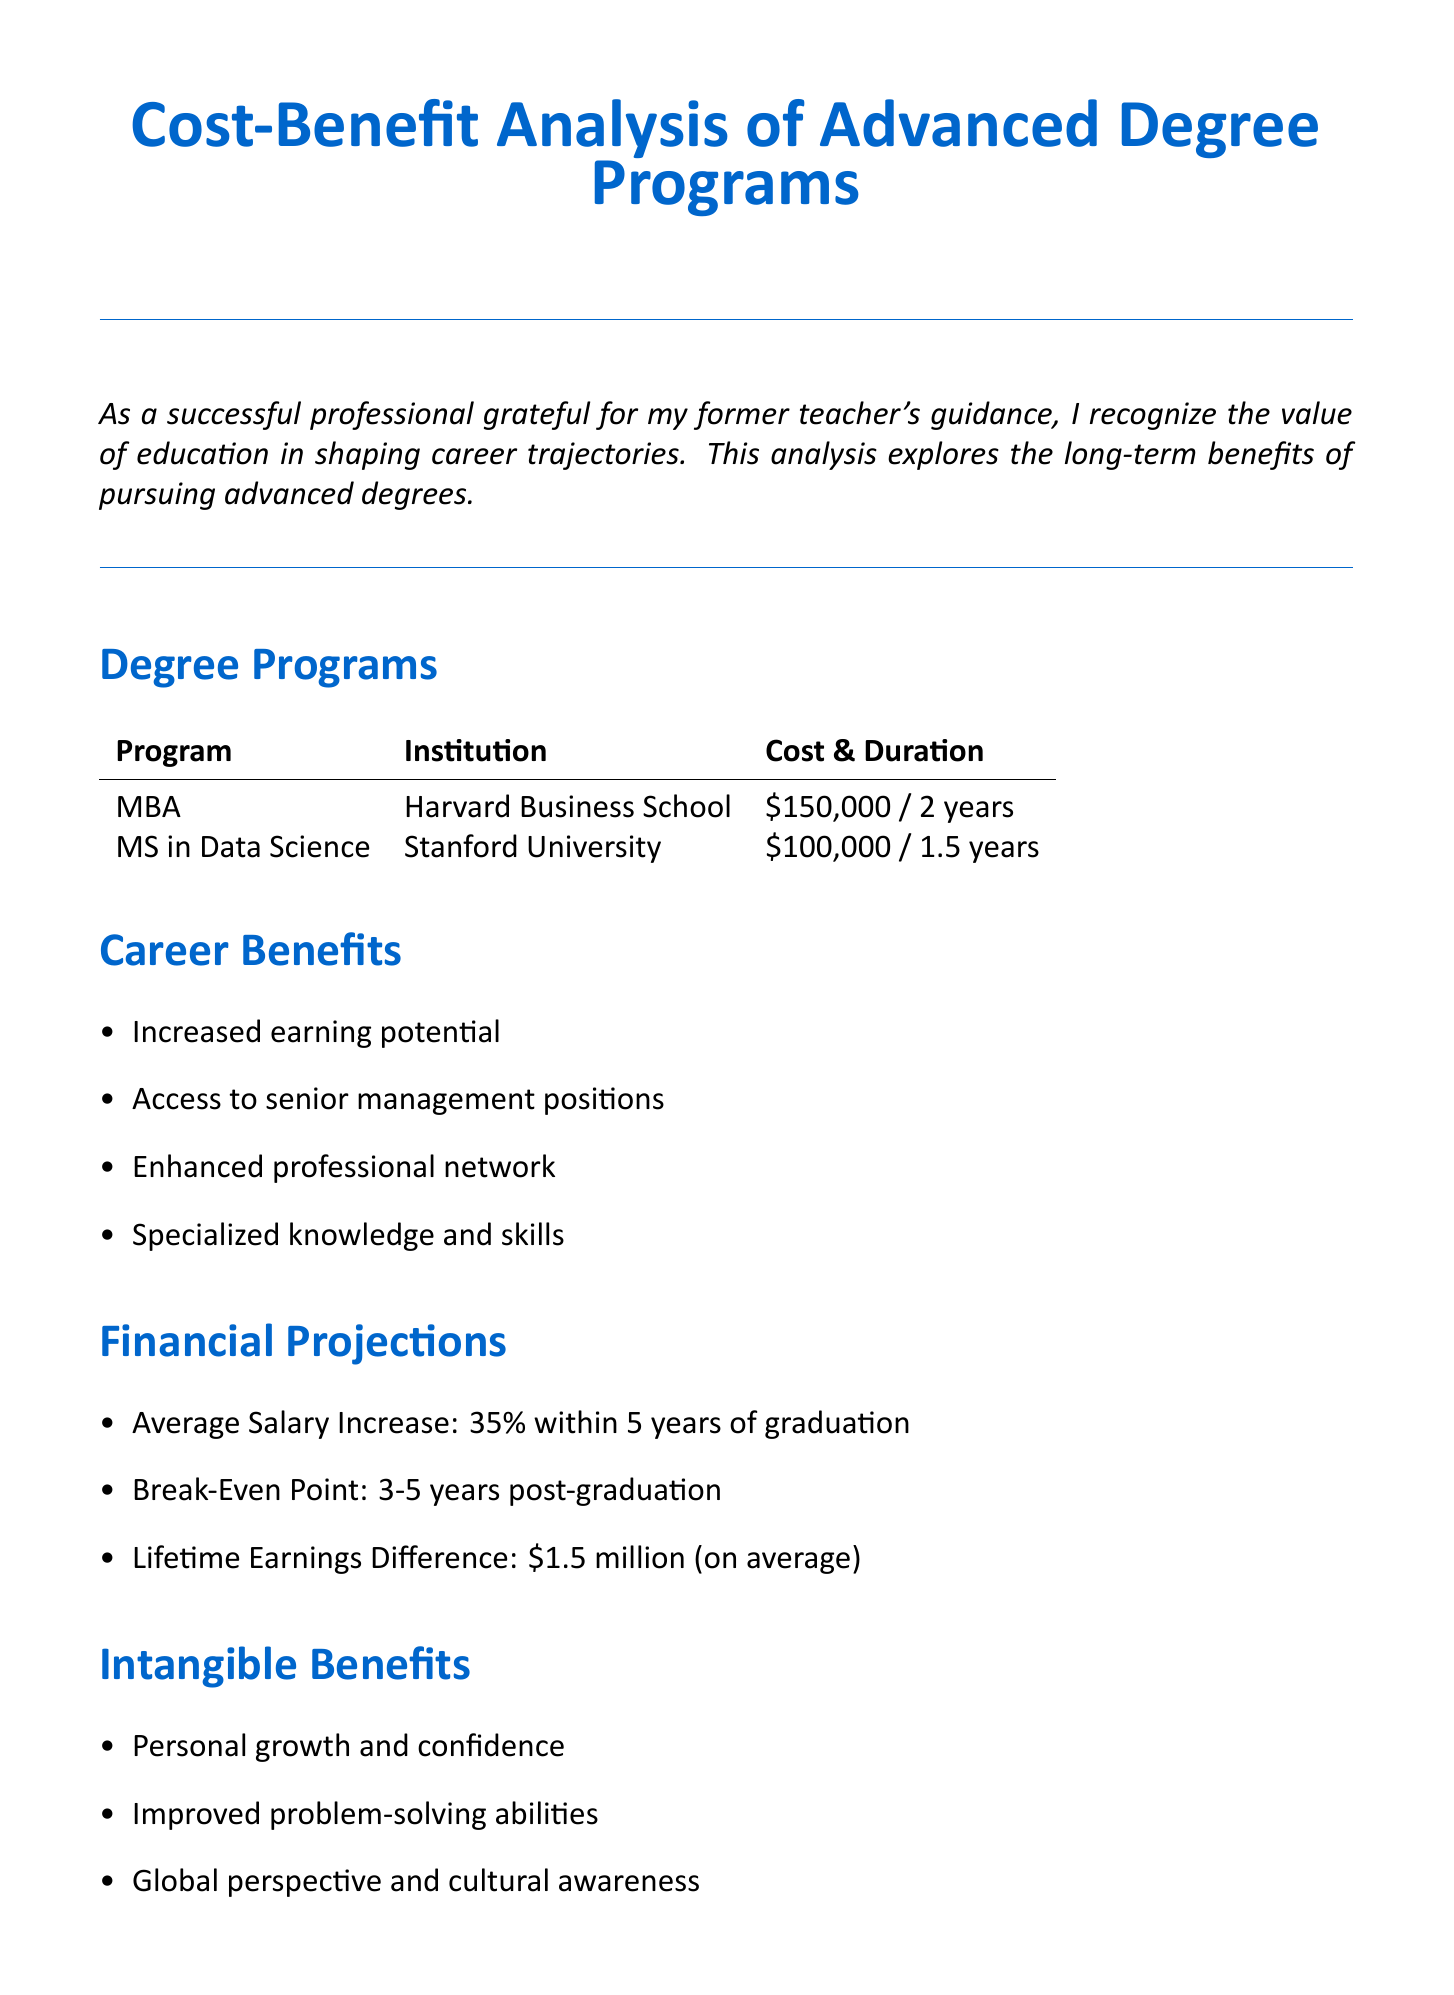What is the title of the document? The title of the document is specified at the beginning, summarizing the content focus.
Answer: Cost-Benefit Analysis of Advanced Degree Programs: Long-Term Career Benefits What are the two degree programs listed? The document provides two specific advanced degree programs as examples.
Answer: MBA, MS in Data Science What is the cost of the Master of Business Administration? The cost of the MBA program is stated in the degree programs section.
Answer: $150,000 What is the average salary increase mentioned? The average salary increase is an important financial projection highlighted in the analysis.
Answer: 35% within 5 years of graduation What is the lifetime earnings difference for graduates? The document summarizes the financial benefit in terms of lifetime earnings difference.
Answer: $1.5 million (on average) What are two intangible benefits mentioned? The intangible benefits section lists important personal growth aspects related to advanced degrees.
Answer: Personal growth and confidence; Improved problem-solving abilities How long does it take to break even after graduation? The break-even point is specified in the financial projections and indicates payback time.
Answer: 3-5 years post-graduation What institution offers the Master of Science in Data Science? The institution offering the MS in Data Science is explicitly stated in the degree programs section.
Answer: Stanford University What does the conclusion emphasize about education? The conclusion section reflects on the perspective of education as a long-term investment.
Answer: Education is an investment in oneself that pays lifelong dividends 